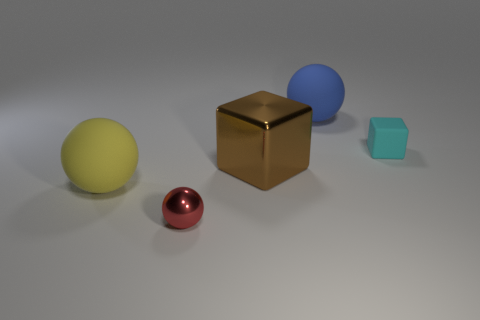Subtract all big balls. How many balls are left? 1 Add 2 big purple blocks. How many objects exist? 7 Subtract all cyan blocks. How many blocks are left? 1 Subtract all rubber spheres. Subtract all small cyan rubber blocks. How many objects are left? 2 Add 5 big yellow things. How many big yellow things are left? 6 Add 3 big brown things. How many big brown things exist? 4 Subtract 0 brown cylinders. How many objects are left? 5 Subtract all balls. How many objects are left? 2 Subtract all red balls. Subtract all yellow cylinders. How many balls are left? 2 